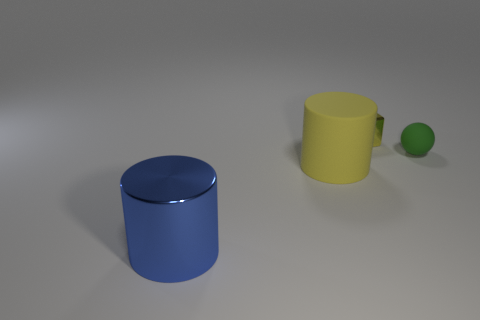Is the number of blocks in front of the sphere less than the number of small yellow metallic objects on the right side of the large yellow cylinder?
Your answer should be very brief. Yes. Is the color of the tiny thing that is in front of the yellow metal cube the same as the cylinder behind the blue metallic cylinder?
Offer a terse response. No. What is the material of the object that is both right of the large blue object and in front of the tiny green matte sphere?
Provide a succinct answer. Rubber. Are there any small blue shiny blocks?
Give a very brief answer. No. There is another object that is the same material as the blue object; what shape is it?
Give a very brief answer. Cube. There is a yellow matte object; is its shape the same as the shiny thing behind the blue shiny cylinder?
Provide a short and direct response. No. There is a cylinder that is left of the matte object to the left of the tiny matte object; what is it made of?
Provide a succinct answer. Metal. How many other things are the same shape as the green object?
Your answer should be compact. 0. Does the metallic thing that is on the right side of the big shiny thing have the same shape as the metal thing that is in front of the rubber sphere?
Your response must be concise. No. Is there anything else that has the same material as the blue thing?
Make the answer very short. Yes. 